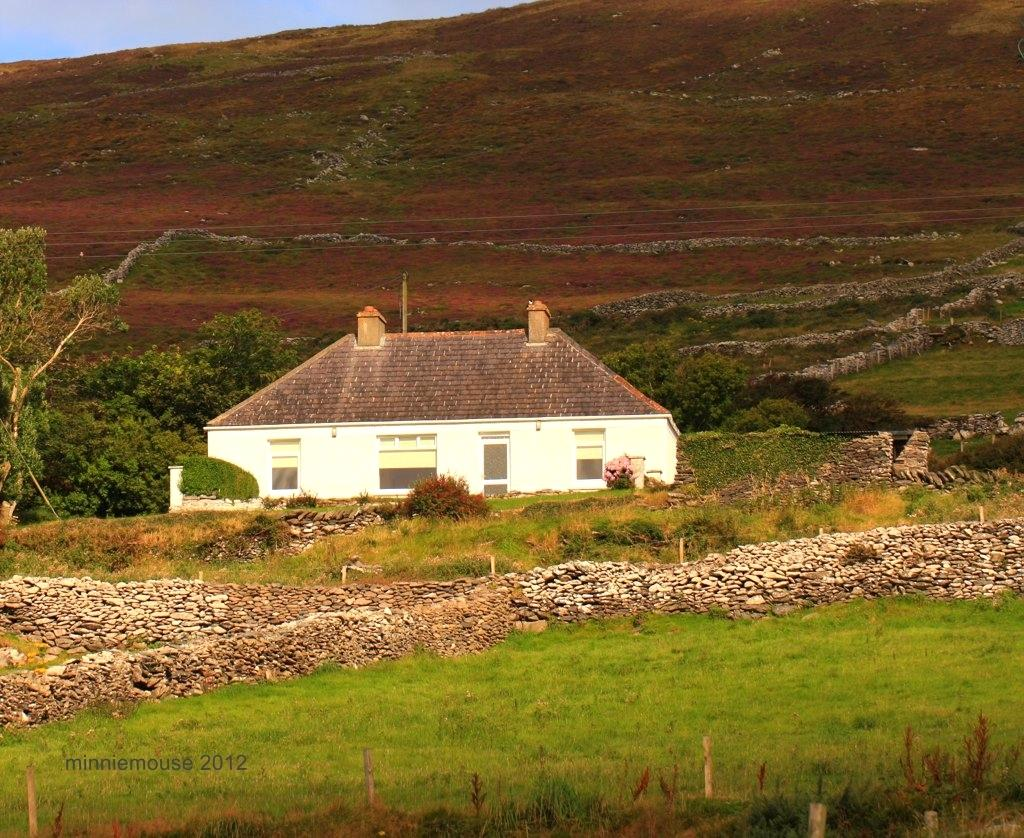What type of landscape is depicted in the image? The image features fields. What structures can be seen in the image? There are rock walls in the image. What buildings are visible in the background? There is a house in the background of the image. What type of vegetation is present in the background? There are trees in the background of the image. What geographical feature is visible in the distance? There is a mountain in the background of the image. What type of pencil can be seen in the image? There is no pencil present in the image. How does the stem of the tree in the image affect the friction between the tree and the ground? There is no mention of a tree with a stem in the image, and therefore we cannot determine its effect on friction. 